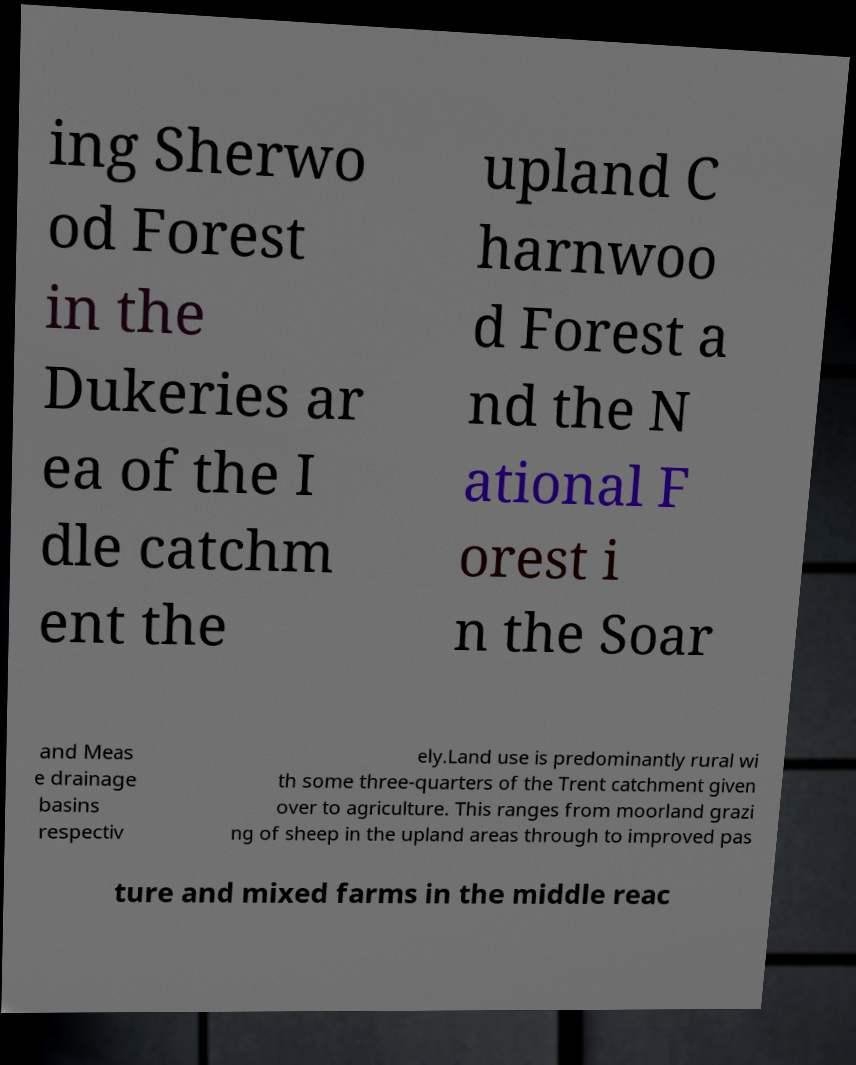What messages or text are displayed in this image? I need them in a readable, typed format. ing Sherwo od Forest in the Dukeries ar ea of the I dle catchm ent the upland C harnwoo d Forest a nd the N ational F orest i n the Soar and Meas e drainage basins respectiv ely.Land use is predominantly rural wi th some three-quarters of the Trent catchment given over to agriculture. This ranges from moorland grazi ng of sheep in the upland areas through to improved pas ture and mixed farms in the middle reac 